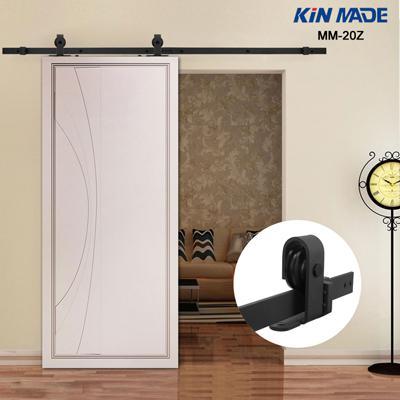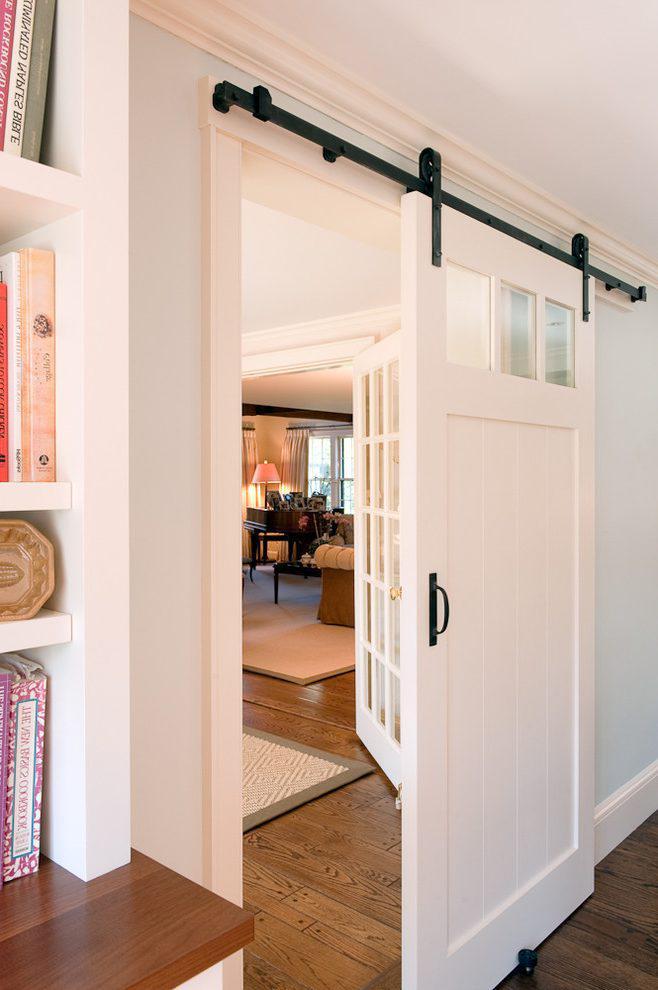The first image is the image on the left, the second image is the image on the right. Evaluate the accuracy of this statement regarding the images: "There is a lamp in one of the images.". Is it true? Answer yes or no. No. 